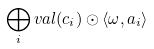Convert formula to latex. <formula><loc_0><loc_0><loc_500><loc_500>\bigoplus _ { i } v a l ( c _ { i } ) \odot \langle \omega , a _ { i } \rangle</formula> 